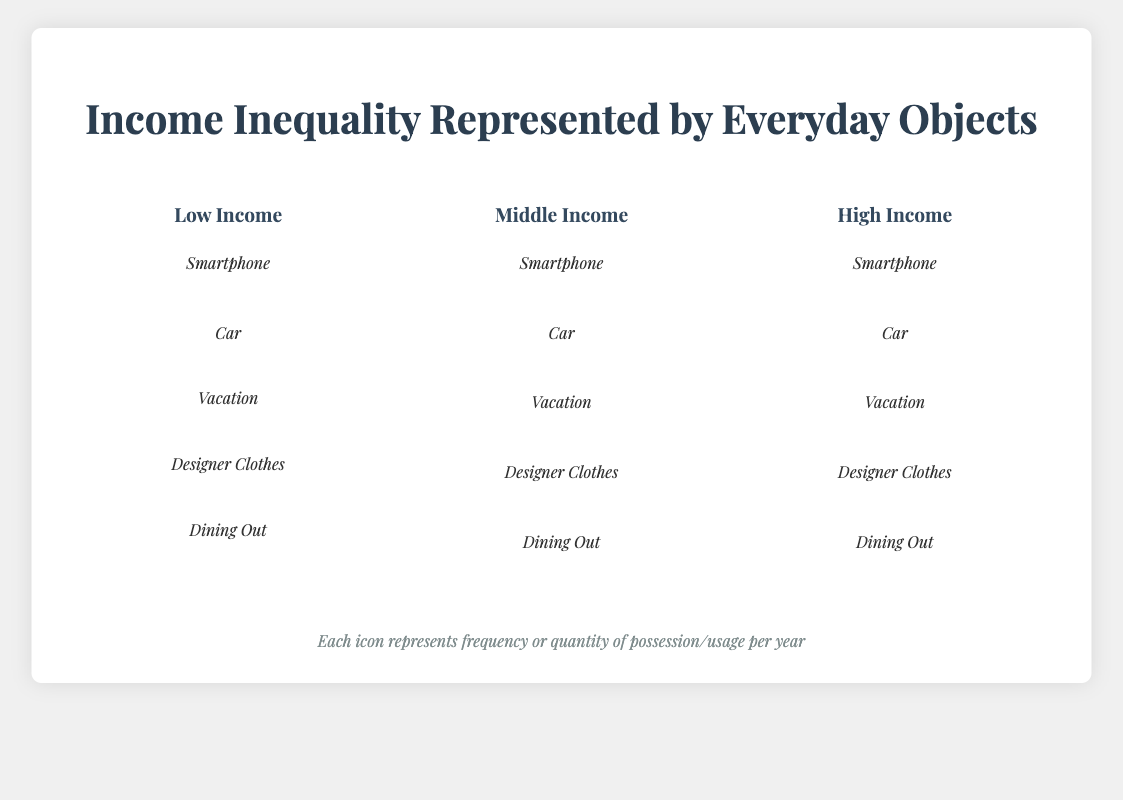What is the title of the figure? The title is prominently displayed at the top of the figure in large, bold text.
Answer: Income Inequality Represented by Everyday Objects Which object is represented the most frequently in the High Income category? By looking at the number of icons in each object category for the High Income group, Dining Out has the most icons.
Answer: Dining Out How many times does the Middle Income category possess a car? The figure uses icon indicators. For the Car object in the Middle Income category, there is 1 car icon.
Answer: 1 Which income category has the fewest designer clothes? By comparing the number of icons for Designer Clothes in each income category, the Low Income category has no icons for Designer Clothes.
Answer: Low Income How many vacations does the High Income category take compared to the Low Income category? By counting the number of icons (plane symbols) for the Vacation object in both categories, High Income has 4 and Low Income has 0. The difference is 4.
Answer: 4 What is the total number of smartphones owned across all categories? Adding the number of smartphone icons across Low Income (1), Middle Income (2), and High Income (5), we get a total sum of 8.
Answer: 8 How does the frequency of Dining Out differ between Low Income and High Income categories? The Dining Out object shows 1 icon for Low Income and 8 icons for High Income. The difference is 7.
Answer: 7 Which income category has a higher frequency of vacationing: Low Income or Middle Income? By looking at the number of plane icons, Middle Income has 1 icon and Low Income has 0. So, Middle Income has a higher frequency.
Answer: Middle Income What is the average number of possession/usage of cars across all categories? Summing the car icon counts: Low Income (0), Middle Income (1), and High Income (3), gives a total of 4. Dividing by 3 categories, the average is 4/3 ≈ 1.33.
Answer: 1.33 